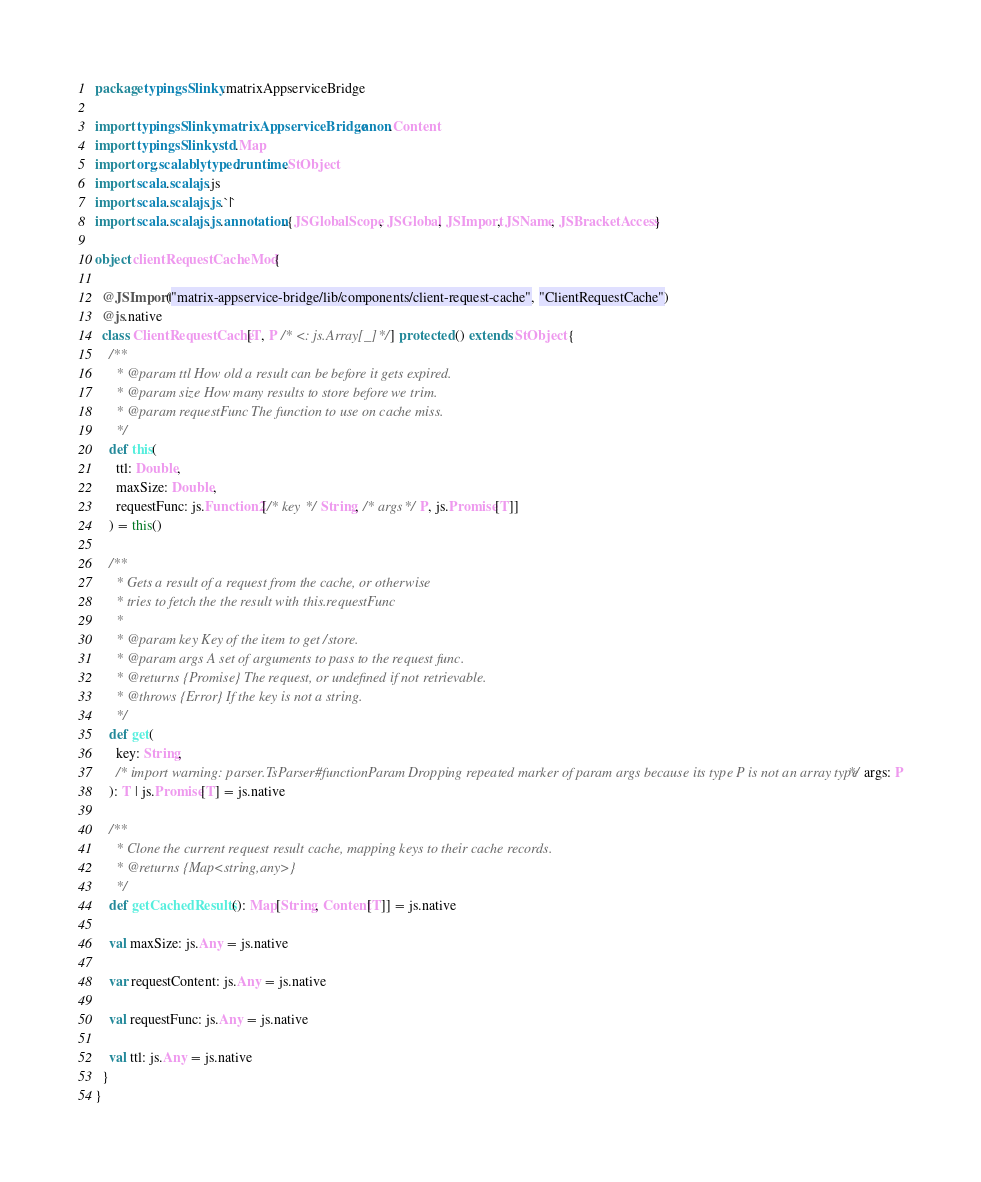<code> <loc_0><loc_0><loc_500><loc_500><_Scala_>package typingsSlinky.matrixAppserviceBridge

import typingsSlinky.matrixAppserviceBridge.anon.Content
import typingsSlinky.std.Map
import org.scalablytyped.runtime.StObject
import scala.scalajs.js
import scala.scalajs.js.`|`
import scala.scalajs.js.annotation.{JSGlobalScope, JSGlobal, JSImport, JSName, JSBracketAccess}

object clientRequestCacheMod {
  
  @JSImport("matrix-appservice-bridge/lib/components/client-request-cache", "ClientRequestCache")
  @js.native
  class ClientRequestCache[T, P /* <: js.Array[_] */] protected () extends StObject {
    /**
      * @param ttl How old a result can be before it gets expired.
      * @param size How many results to store before we trim.
      * @param requestFunc The function to use on cache miss.
      */
    def this(
      ttl: Double,
      maxSize: Double,
      requestFunc: js.Function2[/* key */ String, /* args */ P, js.Promise[T]]
    ) = this()
    
    /**
      * Gets a result of a request from the cache, or otherwise
      * tries to fetch the the result with this.requestFunc
      *
      * @param key Key of the item to get/store.
      * @param args A set of arguments to pass to the request func.
      * @returns {Promise} The request, or undefined if not retrievable.
      * @throws {Error} If the key is not a string.
      */
    def get(
      key: String,
      /* import warning: parser.TsParser#functionParam Dropping repeated marker of param args because its type P is not an array type */ args: P
    ): T | js.Promise[T] = js.native
    
    /**
      * Clone the current request result cache, mapping keys to their cache records.
      * @returns {Map<string,any>}
      */
    def getCachedResults(): Map[String, Content[T]] = js.native
    
    val maxSize: js.Any = js.native
    
    var requestContent: js.Any = js.native
    
    val requestFunc: js.Any = js.native
    
    val ttl: js.Any = js.native
  }
}
</code> 